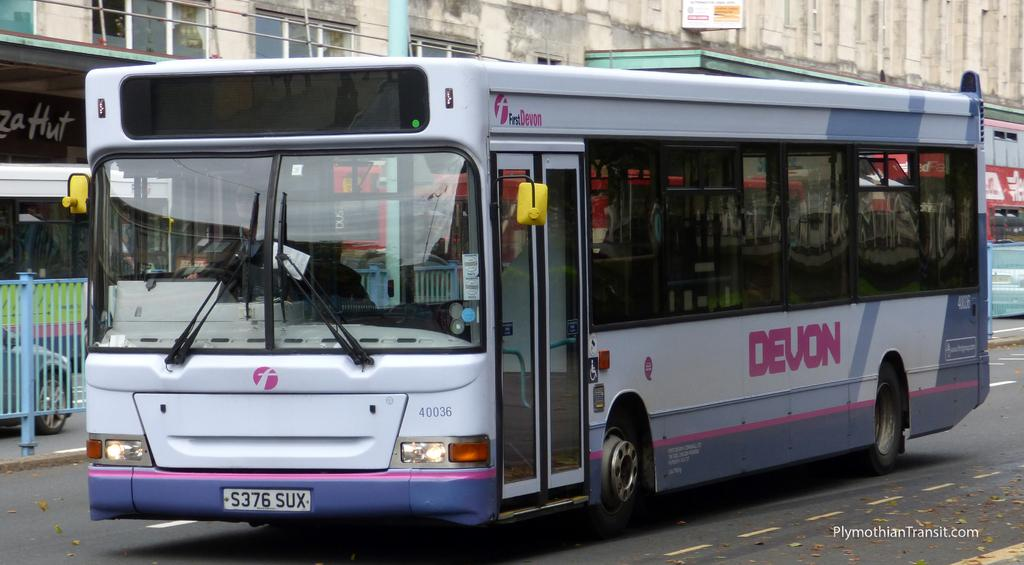<image>
Write a terse but informative summary of the picture. A white and blue bus driving down the street that has the word Devon on it 